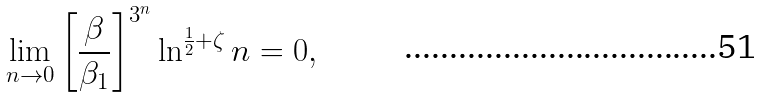Convert formula to latex. <formula><loc_0><loc_0><loc_500><loc_500>\lim _ { n \to 0 } \left [ \frac { \beta } { \beta _ { 1 } } \right ] ^ { 3 ^ { n } } \ln ^ { \frac { 1 } { 2 } + \zeta } n = 0 ,</formula> 